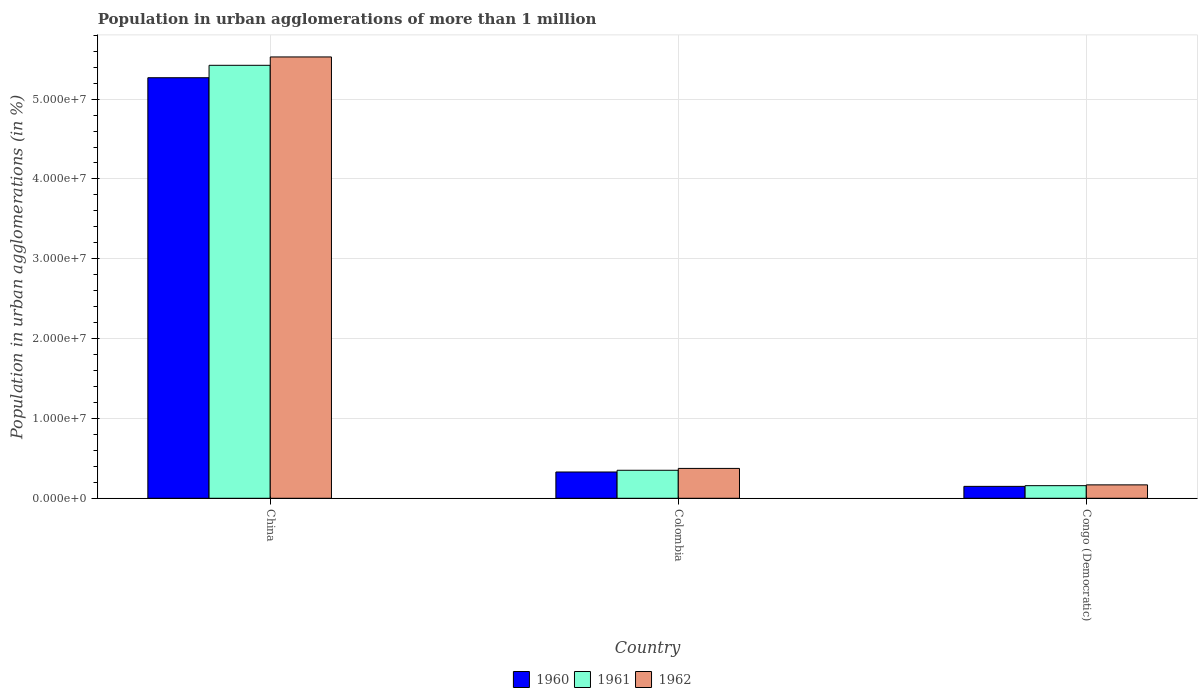How many different coloured bars are there?
Your answer should be compact. 3. Are the number of bars per tick equal to the number of legend labels?
Your answer should be very brief. Yes. Are the number of bars on each tick of the X-axis equal?
Keep it short and to the point. Yes. How many bars are there on the 2nd tick from the left?
Provide a succinct answer. 3. How many bars are there on the 1st tick from the right?
Provide a succinct answer. 3. What is the label of the 1st group of bars from the left?
Give a very brief answer. China. What is the population in urban agglomerations in 1960 in China?
Offer a very short reply. 5.27e+07. Across all countries, what is the maximum population in urban agglomerations in 1960?
Offer a terse response. 5.27e+07. Across all countries, what is the minimum population in urban agglomerations in 1961?
Your answer should be compact. 1.58e+06. In which country was the population in urban agglomerations in 1960 maximum?
Keep it short and to the point. China. In which country was the population in urban agglomerations in 1961 minimum?
Offer a terse response. Congo (Democratic). What is the total population in urban agglomerations in 1960 in the graph?
Offer a very short reply. 5.75e+07. What is the difference between the population in urban agglomerations in 1961 in China and that in Congo (Democratic)?
Your answer should be compact. 5.27e+07. What is the difference between the population in urban agglomerations in 1961 in Colombia and the population in urban agglomerations in 1960 in China?
Your answer should be compact. -4.92e+07. What is the average population in urban agglomerations in 1961 per country?
Your answer should be very brief. 1.98e+07. What is the difference between the population in urban agglomerations of/in 1960 and population in urban agglomerations of/in 1961 in Congo (Democratic)?
Your answer should be compact. -8.86e+04. What is the ratio of the population in urban agglomerations in 1960 in China to that in Congo (Democratic)?
Keep it short and to the point. 35.31. What is the difference between the highest and the second highest population in urban agglomerations in 1962?
Offer a terse response. 2.06e+06. What is the difference between the highest and the lowest population in urban agglomerations in 1961?
Offer a terse response. 5.27e+07. In how many countries, is the population in urban agglomerations in 1962 greater than the average population in urban agglomerations in 1962 taken over all countries?
Provide a short and direct response. 1. Is the sum of the population in urban agglomerations in 1961 in China and Colombia greater than the maximum population in urban agglomerations in 1962 across all countries?
Offer a terse response. Yes. What does the 1st bar from the left in China represents?
Provide a succinct answer. 1960. What does the 1st bar from the right in China represents?
Your answer should be very brief. 1962. How many bars are there?
Your answer should be very brief. 9. How many countries are there in the graph?
Your answer should be very brief. 3. Are the values on the major ticks of Y-axis written in scientific E-notation?
Provide a short and direct response. Yes. Where does the legend appear in the graph?
Your answer should be compact. Bottom center. How many legend labels are there?
Offer a very short reply. 3. What is the title of the graph?
Make the answer very short. Population in urban agglomerations of more than 1 million. Does "1981" appear as one of the legend labels in the graph?
Give a very brief answer. No. What is the label or title of the Y-axis?
Your answer should be very brief. Population in urban agglomerations (in %). What is the Population in urban agglomerations (in %) of 1960 in China?
Offer a very short reply. 5.27e+07. What is the Population in urban agglomerations (in %) of 1961 in China?
Keep it short and to the point. 5.42e+07. What is the Population in urban agglomerations (in %) of 1962 in China?
Your response must be concise. 5.53e+07. What is the Population in urban agglomerations (in %) of 1960 in Colombia?
Ensure brevity in your answer.  3.29e+06. What is the Population in urban agglomerations (in %) in 1961 in Colombia?
Give a very brief answer. 3.51e+06. What is the Population in urban agglomerations (in %) of 1962 in Colombia?
Make the answer very short. 3.74e+06. What is the Population in urban agglomerations (in %) in 1960 in Congo (Democratic)?
Your answer should be very brief. 1.49e+06. What is the Population in urban agglomerations (in %) of 1961 in Congo (Democratic)?
Offer a very short reply. 1.58e+06. What is the Population in urban agglomerations (in %) in 1962 in Congo (Democratic)?
Your answer should be compact. 1.68e+06. Across all countries, what is the maximum Population in urban agglomerations (in %) in 1960?
Keep it short and to the point. 5.27e+07. Across all countries, what is the maximum Population in urban agglomerations (in %) in 1961?
Make the answer very short. 5.42e+07. Across all countries, what is the maximum Population in urban agglomerations (in %) in 1962?
Offer a very short reply. 5.53e+07. Across all countries, what is the minimum Population in urban agglomerations (in %) of 1960?
Provide a succinct answer. 1.49e+06. Across all countries, what is the minimum Population in urban agglomerations (in %) of 1961?
Keep it short and to the point. 1.58e+06. Across all countries, what is the minimum Population in urban agglomerations (in %) of 1962?
Your answer should be compact. 1.68e+06. What is the total Population in urban agglomerations (in %) of 1960 in the graph?
Your answer should be very brief. 5.75e+07. What is the total Population in urban agglomerations (in %) in 1961 in the graph?
Provide a succinct answer. 5.93e+07. What is the total Population in urban agglomerations (in %) of 1962 in the graph?
Make the answer very short. 6.07e+07. What is the difference between the Population in urban agglomerations (in %) in 1960 in China and that in Colombia?
Provide a succinct answer. 4.94e+07. What is the difference between the Population in urban agglomerations (in %) of 1961 in China and that in Colombia?
Your answer should be compact. 5.07e+07. What is the difference between the Population in urban agglomerations (in %) of 1962 in China and that in Colombia?
Offer a very short reply. 5.15e+07. What is the difference between the Population in urban agglomerations (in %) in 1960 in China and that in Congo (Democratic)?
Give a very brief answer. 5.12e+07. What is the difference between the Population in urban agglomerations (in %) of 1961 in China and that in Congo (Democratic)?
Your response must be concise. 5.27e+07. What is the difference between the Population in urban agglomerations (in %) in 1962 in China and that in Congo (Democratic)?
Offer a terse response. 5.36e+07. What is the difference between the Population in urban agglomerations (in %) in 1960 in Colombia and that in Congo (Democratic)?
Your answer should be compact. 1.80e+06. What is the difference between the Population in urban agglomerations (in %) in 1961 in Colombia and that in Congo (Democratic)?
Offer a terse response. 1.93e+06. What is the difference between the Population in urban agglomerations (in %) of 1962 in Colombia and that in Congo (Democratic)?
Make the answer very short. 2.06e+06. What is the difference between the Population in urban agglomerations (in %) of 1960 in China and the Population in urban agglomerations (in %) of 1961 in Colombia?
Your answer should be very brief. 4.92e+07. What is the difference between the Population in urban agglomerations (in %) of 1960 in China and the Population in urban agglomerations (in %) of 1962 in Colombia?
Make the answer very short. 4.89e+07. What is the difference between the Population in urban agglomerations (in %) of 1961 in China and the Population in urban agglomerations (in %) of 1962 in Colombia?
Ensure brevity in your answer.  5.05e+07. What is the difference between the Population in urban agglomerations (in %) of 1960 in China and the Population in urban agglomerations (in %) of 1961 in Congo (Democratic)?
Your response must be concise. 5.11e+07. What is the difference between the Population in urban agglomerations (in %) in 1960 in China and the Population in urban agglomerations (in %) in 1962 in Congo (Democratic)?
Your answer should be compact. 5.10e+07. What is the difference between the Population in urban agglomerations (in %) of 1961 in China and the Population in urban agglomerations (in %) of 1962 in Congo (Democratic)?
Offer a very short reply. 5.26e+07. What is the difference between the Population in urban agglomerations (in %) in 1960 in Colombia and the Population in urban agglomerations (in %) in 1961 in Congo (Democratic)?
Your response must be concise. 1.71e+06. What is the difference between the Population in urban agglomerations (in %) of 1960 in Colombia and the Population in urban agglomerations (in %) of 1962 in Congo (Democratic)?
Keep it short and to the point. 1.61e+06. What is the difference between the Population in urban agglomerations (in %) of 1961 in Colombia and the Population in urban agglomerations (in %) of 1962 in Congo (Democratic)?
Your answer should be compact. 1.83e+06. What is the average Population in urban agglomerations (in %) of 1960 per country?
Your answer should be very brief. 1.92e+07. What is the average Population in urban agglomerations (in %) of 1961 per country?
Your response must be concise. 1.98e+07. What is the average Population in urban agglomerations (in %) of 1962 per country?
Provide a short and direct response. 2.02e+07. What is the difference between the Population in urban agglomerations (in %) in 1960 and Population in urban agglomerations (in %) in 1961 in China?
Provide a short and direct response. -1.56e+06. What is the difference between the Population in urban agglomerations (in %) of 1960 and Population in urban agglomerations (in %) of 1962 in China?
Provide a short and direct response. -2.60e+06. What is the difference between the Population in urban agglomerations (in %) of 1961 and Population in urban agglomerations (in %) of 1962 in China?
Ensure brevity in your answer.  -1.05e+06. What is the difference between the Population in urban agglomerations (in %) of 1960 and Population in urban agglomerations (in %) of 1961 in Colombia?
Provide a short and direct response. -2.17e+05. What is the difference between the Population in urban agglomerations (in %) of 1960 and Population in urban agglomerations (in %) of 1962 in Colombia?
Ensure brevity in your answer.  -4.48e+05. What is the difference between the Population in urban agglomerations (in %) in 1961 and Population in urban agglomerations (in %) in 1962 in Colombia?
Provide a succinct answer. -2.32e+05. What is the difference between the Population in urban agglomerations (in %) in 1960 and Population in urban agglomerations (in %) in 1961 in Congo (Democratic)?
Provide a short and direct response. -8.86e+04. What is the difference between the Population in urban agglomerations (in %) in 1960 and Population in urban agglomerations (in %) in 1962 in Congo (Democratic)?
Make the answer very short. -1.89e+05. What is the difference between the Population in urban agglomerations (in %) of 1961 and Population in urban agglomerations (in %) of 1962 in Congo (Democratic)?
Offer a very short reply. -1.00e+05. What is the ratio of the Population in urban agglomerations (in %) of 1960 in China to that in Colombia?
Provide a succinct answer. 16. What is the ratio of the Population in urban agglomerations (in %) of 1961 in China to that in Colombia?
Provide a short and direct response. 15.46. What is the ratio of the Population in urban agglomerations (in %) of 1962 in China to that in Colombia?
Keep it short and to the point. 14.78. What is the ratio of the Population in urban agglomerations (in %) of 1960 in China to that in Congo (Democratic)?
Provide a succinct answer. 35.31. What is the ratio of the Population in urban agglomerations (in %) of 1961 in China to that in Congo (Democratic)?
Give a very brief answer. 34.32. What is the ratio of the Population in urban agglomerations (in %) in 1962 in China to that in Congo (Democratic)?
Keep it short and to the point. 32.9. What is the ratio of the Population in urban agglomerations (in %) of 1960 in Colombia to that in Congo (Democratic)?
Keep it short and to the point. 2.21. What is the ratio of the Population in urban agglomerations (in %) in 1961 in Colombia to that in Congo (Democratic)?
Provide a succinct answer. 2.22. What is the ratio of the Population in urban agglomerations (in %) in 1962 in Colombia to that in Congo (Democratic)?
Offer a terse response. 2.23. What is the difference between the highest and the second highest Population in urban agglomerations (in %) of 1960?
Your answer should be very brief. 4.94e+07. What is the difference between the highest and the second highest Population in urban agglomerations (in %) in 1961?
Your response must be concise. 5.07e+07. What is the difference between the highest and the second highest Population in urban agglomerations (in %) of 1962?
Keep it short and to the point. 5.15e+07. What is the difference between the highest and the lowest Population in urban agglomerations (in %) of 1960?
Ensure brevity in your answer.  5.12e+07. What is the difference between the highest and the lowest Population in urban agglomerations (in %) of 1961?
Your answer should be very brief. 5.27e+07. What is the difference between the highest and the lowest Population in urban agglomerations (in %) in 1962?
Your answer should be compact. 5.36e+07. 